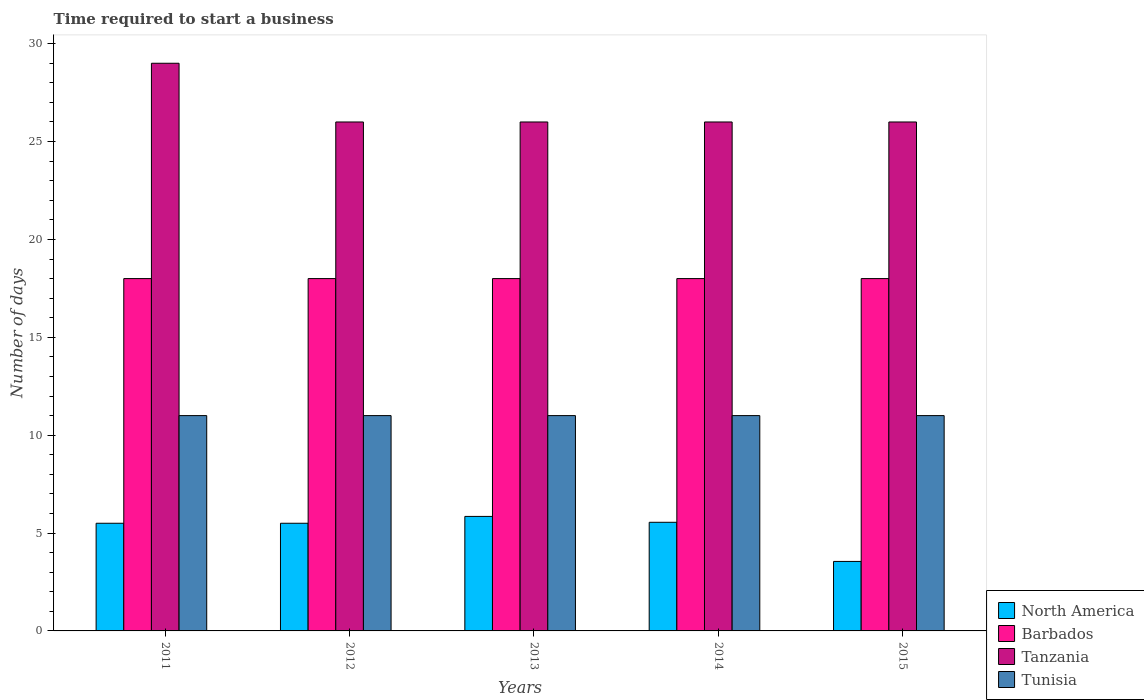How many different coloured bars are there?
Ensure brevity in your answer.  4. How many groups of bars are there?
Your answer should be compact. 5. Are the number of bars on each tick of the X-axis equal?
Ensure brevity in your answer.  Yes. What is the number of days required to start a business in Tunisia in 2011?
Give a very brief answer. 11. Across all years, what is the minimum number of days required to start a business in Barbados?
Provide a short and direct response. 18. In which year was the number of days required to start a business in Tanzania maximum?
Your answer should be very brief. 2011. In which year was the number of days required to start a business in North America minimum?
Keep it short and to the point. 2015. What is the total number of days required to start a business in Tunisia in the graph?
Your answer should be compact. 55. What is the average number of days required to start a business in Tanzania per year?
Your answer should be compact. 26.6. In the year 2014, what is the difference between the number of days required to start a business in Barbados and number of days required to start a business in Tunisia?
Offer a terse response. 7. In how many years, is the number of days required to start a business in Barbados greater than 7 days?
Make the answer very short. 5. What is the ratio of the number of days required to start a business in Tanzania in 2011 to that in 2012?
Provide a succinct answer. 1.12. Is the difference between the number of days required to start a business in Barbados in 2011 and 2012 greater than the difference between the number of days required to start a business in Tunisia in 2011 and 2012?
Keep it short and to the point. No. What is the difference between the highest and the second highest number of days required to start a business in Tanzania?
Provide a short and direct response. 3. In how many years, is the number of days required to start a business in Tanzania greater than the average number of days required to start a business in Tanzania taken over all years?
Provide a succinct answer. 1. Is it the case that in every year, the sum of the number of days required to start a business in Tunisia and number of days required to start a business in North America is greater than the sum of number of days required to start a business in Tanzania and number of days required to start a business in Barbados?
Provide a short and direct response. No. What does the 2nd bar from the left in 2013 represents?
Give a very brief answer. Barbados. What does the 3rd bar from the right in 2012 represents?
Make the answer very short. Barbados. Is it the case that in every year, the sum of the number of days required to start a business in Tunisia and number of days required to start a business in Tanzania is greater than the number of days required to start a business in Barbados?
Your answer should be very brief. Yes. How many bars are there?
Offer a very short reply. 20. Are all the bars in the graph horizontal?
Your response must be concise. No. How many years are there in the graph?
Provide a succinct answer. 5. Does the graph contain any zero values?
Offer a terse response. No. Does the graph contain grids?
Your response must be concise. No. Where does the legend appear in the graph?
Make the answer very short. Bottom right. What is the title of the graph?
Your answer should be compact. Time required to start a business. What is the label or title of the X-axis?
Offer a very short reply. Years. What is the label or title of the Y-axis?
Provide a succinct answer. Number of days. What is the Number of days in North America in 2011?
Ensure brevity in your answer.  5.5. What is the Number of days of Tunisia in 2011?
Offer a very short reply. 11. What is the Number of days of Tanzania in 2012?
Offer a very short reply. 26. What is the Number of days of North America in 2013?
Give a very brief answer. 5.85. What is the Number of days in Barbados in 2013?
Make the answer very short. 18. What is the Number of days of Tunisia in 2013?
Ensure brevity in your answer.  11. What is the Number of days of North America in 2014?
Keep it short and to the point. 5.55. What is the Number of days in Tanzania in 2014?
Offer a very short reply. 26. What is the Number of days in North America in 2015?
Keep it short and to the point. 3.55. What is the Number of days in Tanzania in 2015?
Provide a short and direct response. 26. What is the Number of days in Tunisia in 2015?
Give a very brief answer. 11. Across all years, what is the maximum Number of days of North America?
Keep it short and to the point. 5.85. Across all years, what is the maximum Number of days in Tunisia?
Provide a short and direct response. 11. Across all years, what is the minimum Number of days of North America?
Make the answer very short. 3.55. Across all years, what is the minimum Number of days in Barbados?
Your response must be concise. 18. Across all years, what is the minimum Number of days in Tanzania?
Offer a very short reply. 26. Across all years, what is the minimum Number of days in Tunisia?
Keep it short and to the point. 11. What is the total Number of days of North America in the graph?
Ensure brevity in your answer.  25.95. What is the total Number of days of Tanzania in the graph?
Provide a succinct answer. 133. What is the total Number of days of Tunisia in the graph?
Your answer should be compact. 55. What is the difference between the Number of days in North America in 2011 and that in 2012?
Provide a succinct answer. 0. What is the difference between the Number of days in Barbados in 2011 and that in 2012?
Your response must be concise. 0. What is the difference between the Number of days of Tanzania in 2011 and that in 2012?
Provide a succinct answer. 3. What is the difference between the Number of days in Tunisia in 2011 and that in 2012?
Offer a very short reply. 0. What is the difference between the Number of days of North America in 2011 and that in 2013?
Keep it short and to the point. -0.35. What is the difference between the Number of days of Barbados in 2011 and that in 2013?
Your answer should be very brief. 0. What is the difference between the Number of days in Tanzania in 2011 and that in 2013?
Ensure brevity in your answer.  3. What is the difference between the Number of days in North America in 2011 and that in 2014?
Ensure brevity in your answer.  -0.05. What is the difference between the Number of days of Barbados in 2011 and that in 2014?
Give a very brief answer. 0. What is the difference between the Number of days in Tanzania in 2011 and that in 2014?
Offer a very short reply. 3. What is the difference between the Number of days of Tunisia in 2011 and that in 2014?
Keep it short and to the point. 0. What is the difference between the Number of days in North America in 2011 and that in 2015?
Your response must be concise. 1.95. What is the difference between the Number of days in Tanzania in 2011 and that in 2015?
Offer a terse response. 3. What is the difference between the Number of days of Tunisia in 2011 and that in 2015?
Offer a very short reply. 0. What is the difference between the Number of days of North America in 2012 and that in 2013?
Offer a terse response. -0.35. What is the difference between the Number of days in Barbados in 2012 and that in 2013?
Provide a succinct answer. 0. What is the difference between the Number of days of Tanzania in 2012 and that in 2013?
Provide a short and direct response. 0. What is the difference between the Number of days of North America in 2012 and that in 2015?
Your answer should be very brief. 1.95. What is the difference between the Number of days in Tunisia in 2012 and that in 2015?
Provide a short and direct response. 0. What is the difference between the Number of days in Tanzania in 2013 and that in 2014?
Provide a short and direct response. 0. What is the difference between the Number of days of Tunisia in 2013 and that in 2014?
Ensure brevity in your answer.  0. What is the difference between the Number of days in North America in 2013 and that in 2015?
Provide a succinct answer. 2.3. What is the difference between the Number of days of Barbados in 2013 and that in 2015?
Offer a very short reply. 0. What is the difference between the Number of days of Barbados in 2014 and that in 2015?
Offer a very short reply. 0. What is the difference between the Number of days of Tunisia in 2014 and that in 2015?
Offer a terse response. 0. What is the difference between the Number of days of North America in 2011 and the Number of days of Tanzania in 2012?
Your answer should be compact. -20.5. What is the difference between the Number of days of Barbados in 2011 and the Number of days of Tanzania in 2012?
Provide a succinct answer. -8. What is the difference between the Number of days of Barbados in 2011 and the Number of days of Tunisia in 2012?
Keep it short and to the point. 7. What is the difference between the Number of days of North America in 2011 and the Number of days of Tanzania in 2013?
Your answer should be compact. -20.5. What is the difference between the Number of days in Barbados in 2011 and the Number of days in Tanzania in 2013?
Keep it short and to the point. -8. What is the difference between the Number of days in Barbados in 2011 and the Number of days in Tunisia in 2013?
Keep it short and to the point. 7. What is the difference between the Number of days in North America in 2011 and the Number of days in Barbados in 2014?
Offer a very short reply. -12.5. What is the difference between the Number of days in North America in 2011 and the Number of days in Tanzania in 2014?
Offer a terse response. -20.5. What is the difference between the Number of days of North America in 2011 and the Number of days of Tunisia in 2014?
Make the answer very short. -5.5. What is the difference between the Number of days in Barbados in 2011 and the Number of days in Tanzania in 2014?
Ensure brevity in your answer.  -8. What is the difference between the Number of days of Tanzania in 2011 and the Number of days of Tunisia in 2014?
Your answer should be very brief. 18. What is the difference between the Number of days in North America in 2011 and the Number of days in Tanzania in 2015?
Give a very brief answer. -20.5. What is the difference between the Number of days of North America in 2011 and the Number of days of Tunisia in 2015?
Provide a short and direct response. -5.5. What is the difference between the Number of days of North America in 2012 and the Number of days of Tanzania in 2013?
Offer a very short reply. -20.5. What is the difference between the Number of days of Barbados in 2012 and the Number of days of Tanzania in 2013?
Offer a very short reply. -8. What is the difference between the Number of days in Barbados in 2012 and the Number of days in Tunisia in 2013?
Give a very brief answer. 7. What is the difference between the Number of days in North America in 2012 and the Number of days in Barbados in 2014?
Offer a very short reply. -12.5. What is the difference between the Number of days of North America in 2012 and the Number of days of Tanzania in 2014?
Offer a very short reply. -20.5. What is the difference between the Number of days in Barbados in 2012 and the Number of days in Tunisia in 2014?
Offer a very short reply. 7. What is the difference between the Number of days in North America in 2012 and the Number of days in Barbados in 2015?
Offer a very short reply. -12.5. What is the difference between the Number of days in North America in 2012 and the Number of days in Tanzania in 2015?
Provide a succinct answer. -20.5. What is the difference between the Number of days of Barbados in 2012 and the Number of days of Tanzania in 2015?
Your answer should be compact. -8. What is the difference between the Number of days of Tanzania in 2012 and the Number of days of Tunisia in 2015?
Offer a terse response. 15. What is the difference between the Number of days in North America in 2013 and the Number of days in Barbados in 2014?
Your answer should be very brief. -12.15. What is the difference between the Number of days of North America in 2013 and the Number of days of Tanzania in 2014?
Your response must be concise. -20.15. What is the difference between the Number of days of North America in 2013 and the Number of days of Tunisia in 2014?
Make the answer very short. -5.15. What is the difference between the Number of days of Barbados in 2013 and the Number of days of Tanzania in 2014?
Give a very brief answer. -8. What is the difference between the Number of days of Tanzania in 2013 and the Number of days of Tunisia in 2014?
Provide a short and direct response. 15. What is the difference between the Number of days of North America in 2013 and the Number of days of Barbados in 2015?
Give a very brief answer. -12.15. What is the difference between the Number of days in North America in 2013 and the Number of days in Tanzania in 2015?
Provide a short and direct response. -20.15. What is the difference between the Number of days of North America in 2013 and the Number of days of Tunisia in 2015?
Make the answer very short. -5.15. What is the difference between the Number of days in Barbados in 2013 and the Number of days in Tanzania in 2015?
Provide a short and direct response. -8. What is the difference between the Number of days of Barbados in 2013 and the Number of days of Tunisia in 2015?
Give a very brief answer. 7. What is the difference between the Number of days of North America in 2014 and the Number of days of Barbados in 2015?
Your answer should be very brief. -12.45. What is the difference between the Number of days of North America in 2014 and the Number of days of Tanzania in 2015?
Offer a terse response. -20.45. What is the difference between the Number of days of North America in 2014 and the Number of days of Tunisia in 2015?
Your answer should be compact. -5.45. What is the average Number of days in North America per year?
Provide a succinct answer. 5.19. What is the average Number of days of Tanzania per year?
Your answer should be very brief. 26.6. What is the average Number of days in Tunisia per year?
Offer a very short reply. 11. In the year 2011, what is the difference between the Number of days in North America and Number of days in Tanzania?
Your answer should be very brief. -23.5. In the year 2012, what is the difference between the Number of days of North America and Number of days of Tanzania?
Your answer should be compact. -20.5. In the year 2012, what is the difference between the Number of days of Barbados and Number of days of Tanzania?
Ensure brevity in your answer.  -8. In the year 2013, what is the difference between the Number of days in North America and Number of days in Barbados?
Give a very brief answer. -12.15. In the year 2013, what is the difference between the Number of days of North America and Number of days of Tanzania?
Your response must be concise. -20.15. In the year 2013, what is the difference between the Number of days in North America and Number of days in Tunisia?
Give a very brief answer. -5.15. In the year 2013, what is the difference between the Number of days in Barbados and Number of days in Tanzania?
Your answer should be compact. -8. In the year 2013, what is the difference between the Number of days of Barbados and Number of days of Tunisia?
Your response must be concise. 7. In the year 2014, what is the difference between the Number of days in North America and Number of days in Barbados?
Ensure brevity in your answer.  -12.45. In the year 2014, what is the difference between the Number of days of North America and Number of days of Tanzania?
Make the answer very short. -20.45. In the year 2014, what is the difference between the Number of days of North America and Number of days of Tunisia?
Provide a short and direct response. -5.45. In the year 2014, what is the difference between the Number of days in Barbados and Number of days in Tanzania?
Provide a short and direct response. -8. In the year 2015, what is the difference between the Number of days of North America and Number of days of Barbados?
Provide a short and direct response. -14.45. In the year 2015, what is the difference between the Number of days in North America and Number of days in Tanzania?
Provide a succinct answer. -22.45. In the year 2015, what is the difference between the Number of days of North America and Number of days of Tunisia?
Your answer should be compact. -7.45. In the year 2015, what is the difference between the Number of days of Barbados and Number of days of Tanzania?
Your response must be concise. -8. What is the ratio of the Number of days in North America in 2011 to that in 2012?
Your response must be concise. 1. What is the ratio of the Number of days in Tanzania in 2011 to that in 2012?
Your answer should be compact. 1.12. What is the ratio of the Number of days of Tunisia in 2011 to that in 2012?
Your answer should be compact. 1. What is the ratio of the Number of days of North America in 2011 to that in 2013?
Provide a short and direct response. 0.94. What is the ratio of the Number of days in Tanzania in 2011 to that in 2013?
Offer a very short reply. 1.12. What is the ratio of the Number of days of Tunisia in 2011 to that in 2013?
Ensure brevity in your answer.  1. What is the ratio of the Number of days in North America in 2011 to that in 2014?
Make the answer very short. 0.99. What is the ratio of the Number of days in Barbados in 2011 to that in 2014?
Provide a short and direct response. 1. What is the ratio of the Number of days of Tanzania in 2011 to that in 2014?
Provide a short and direct response. 1.12. What is the ratio of the Number of days in North America in 2011 to that in 2015?
Offer a terse response. 1.55. What is the ratio of the Number of days of Tanzania in 2011 to that in 2015?
Your answer should be compact. 1.12. What is the ratio of the Number of days in North America in 2012 to that in 2013?
Keep it short and to the point. 0.94. What is the ratio of the Number of days in Barbados in 2012 to that in 2013?
Offer a very short reply. 1. What is the ratio of the Number of days in Tunisia in 2012 to that in 2013?
Make the answer very short. 1. What is the ratio of the Number of days of North America in 2012 to that in 2014?
Offer a terse response. 0.99. What is the ratio of the Number of days of North America in 2012 to that in 2015?
Make the answer very short. 1.55. What is the ratio of the Number of days of Tanzania in 2012 to that in 2015?
Provide a succinct answer. 1. What is the ratio of the Number of days of North America in 2013 to that in 2014?
Give a very brief answer. 1.05. What is the ratio of the Number of days of Tunisia in 2013 to that in 2014?
Give a very brief answer. 1. What is the ratio of the Number of days in North America in 2013 to that in 2015?
Your answer should be very brief. 1.65. What is the ratio of the Number of days in Tanzania in 2013 to that in 2015?
Your response must be concise. 1. What is the ratio of the Number of days of North America in 2014 to that in 2015?
Your answer should be very brief. 1.56. What is the ratio of the Number of days of Barbados in 2014 to that in 2015?
Make the answer very short. 1. What is the ratio of the Number of days in Tanzania in 2014 to that in 2015?
Your answer should be compact. 1. What is the difference between the highest and the second highest Number of days in Barbados?
Provide a short and direct response. 0. What is the difference between the highest and the second highest Number of days of Tanzania?
Your response must be concise. 3. What is the difference between the highest and the lowest Number of days in North America?
Your response must be concise. 2.3. What is the difference between the highest and the lowest Number of days in Barbados?
Give a very brief answer. 0. What is the difference between the highest and the lowest Number of days of Tanzania?
Give a very brief answer. 3. 